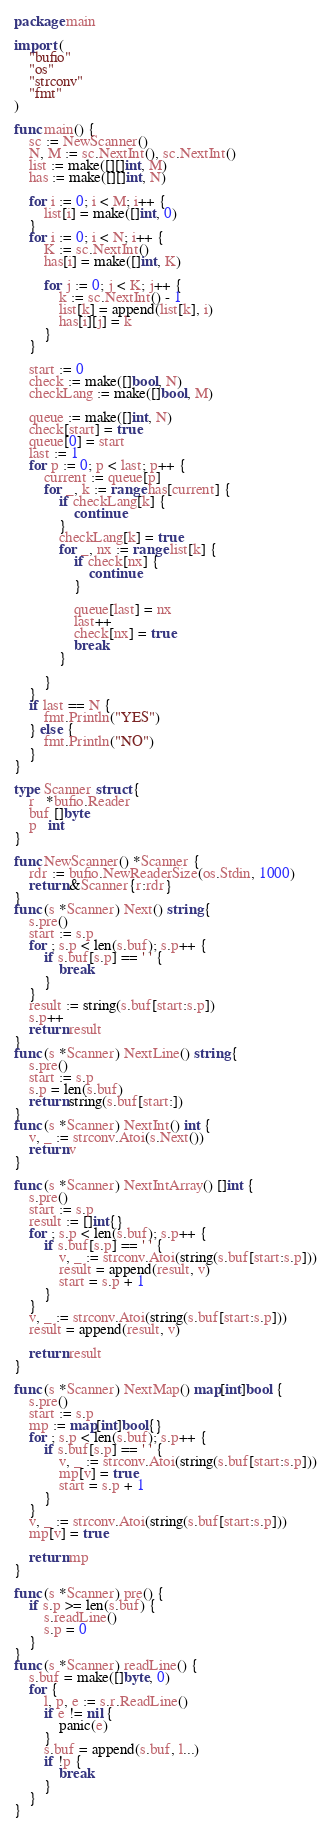<code> <loc_0><loc_0><loc_500><loc_500><_Go_>package main

import (
	"bufio"
	"os"
	"strconv"
	"fmt"
)

func main() {
	sc := NewScanner()
	N, M := sc.NextInt(), sc.NextInt()
	list := make([][]int, M)
	has := make([][]int, N)

	for i := 0; i < M; i++ {
		list[i] = make([]int, 0)
	}
	for i := 0; i < N; i++ {
		K := sc.NextInt()
		has[i] = make([]int, K)

		for j := 0; j < K; j++ {
			k := sc.NextInt() - 1
			list[k] = append(list[k], i)
			has[i][j] = k
		}
	}

	start := 0
	check := make([]bool, N)
	checkLang := make([]bool, M)

	queue := make([]int, N)
	check[start] = true
	queue[0] = start
	last := 1
	for p := 0; p < last; p++ {
		current := queue[p]
		for _, k := range has[current] {
			if checkLang[k] {
				continue
			}
			checkLang[k] = true
			for _, nx := range list[k] {
				if check[nx] {
					continue
				}

				queue[last] = nx
				last++
				check[nx] = true
				break
			}

		}
	}
	if last == N {
		fmt.Println("YES")
	} else {
		fmt.Println("NO")
	}
}

type Scanner struct {
	r   *bufio.Reader
	buf []byte
	p   int
}

func NewScanner() *Scanner {
	rdr := bufio.NewReaderSize(os.Stdin, 1000)
	return &Scanner{r:rdr}
}
func (s *Scanner) Next() string {
	s.pre()
	start := s.p
	for ; s.p < len(s.buf); s.p++ {
		if s.buf[s.p] == ' ' {
			break
		}
	}
	result := string(s.buf[start:s.p])
	s.p++
	return result
}
func (s *Scanner) NextLine() string {
	s.pre()
	start := s.p
	s.p = len(s.buf)
	return string(s.buf[start:])
}
func (s *Scanner) NextInt() int {
	v, _ := strconv.Atoi(s.Next())
	return v
}

func (s *Scanner) NextIntArray() []int {
	s.pre()
	start := s.p
	result := []int{}
	for ; s.p < len(s.buf); s.p++ {
		if s.buf[s.p] == ' ' {
			v, _ := strconv.Atoi(string(s.buf[start:s.p]))
			result = append(result, v)
			start = s.p + 1
		}
	}
	v, _ := strconv.Atoi(string(s.buf[start:s.p]))
	result = append(result, v)

	return result
}

func (s *Scanner) NextMap() map[int]bool {
	s.pre()
	start := s.p
	mp := map[int]bool{}
	for ; s.p < len(s.buf); s.p++ {
		if s.buf[s.p] == ' ' {
			v, _ := strconv.Atoi(string(s.buf[start:s.p]))
			mp[v] = true
			start = s.p + 1
		}
	}
	v, _ := strconv.Atoi(string(s.buf[start:s.p]))
	mp[v] = true

	return mp
}

func (s *Scanner) pre() {
	if s.p >= len(s.buf) {
		s.readLine()
		s.p = 0
	}
}
func (s *Scanner) readLine() {
	s.buf = make([]byte, 0)
	for {
		l, p, e := s.r.ReadLine()
		if e != nil {
			panic(e)
		}
		s.buf = append(s.buf, l...)
		if !p {
			break
		}
	}
}

</code> 